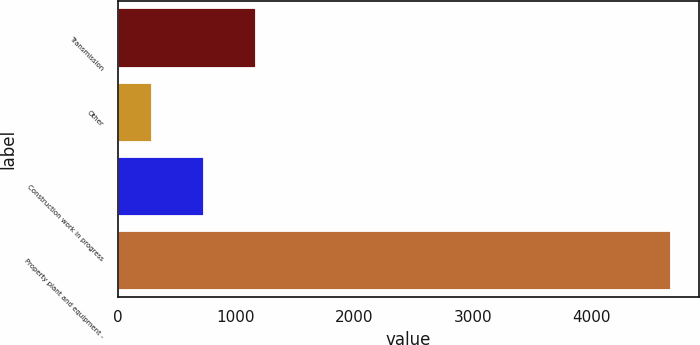Convert chart. <chart><loc_0><loc_0><loc_500><loc_500><bar_chart><fcel>Transmission<fcel>Other<fcel>Construction work in progress<fcel>Property plant and equipment -<nl><fcel>1167<fcel>289<fcel>728<fcel>4679<nl></chart> 